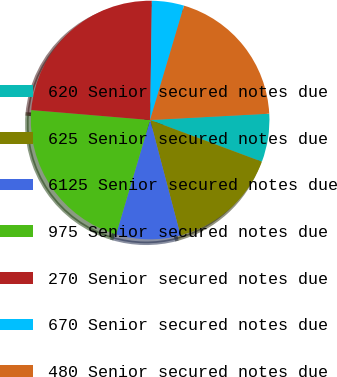Convert chart to OTSL. <chart><loc_0><loc_0><loc_500><loc_500><pie_chart><fcel>620 Senior secured notes due<fcel>625 Senior secured notes due<fcel>6125 Senior secured notes due<fcel>975 Senior secured notes due<fcel>270 Senior secured notes due<fcel>670 Senior secured notes due<fcel>480 Senior secured notes due<nl><fcel>6.53%<fcel>15.22%<fcel>8.7%<fcel>21.73%<fcel>23.9%<fcel>4.36%<fcel>19.56%<nl></chart> 